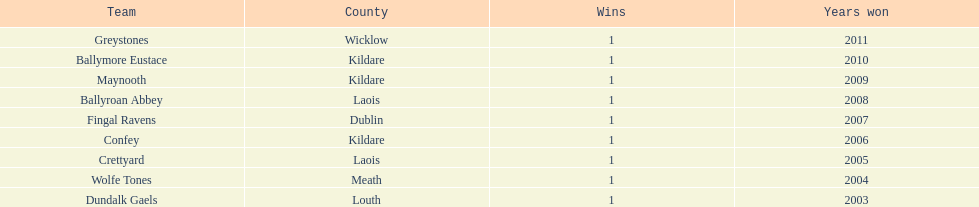What is the total of successes for confey? 1. 